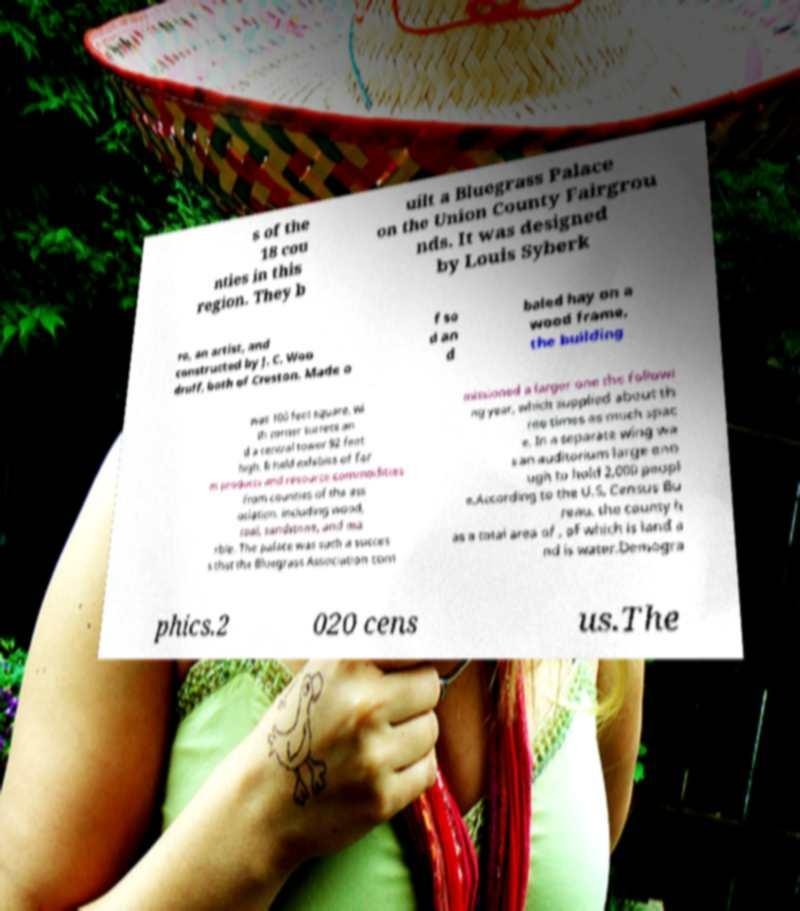Please read and relay the text visible in this image. What does it say? s of the 18 cou nties in this region. They b uilt a Bluegrass Palace on the Union County Fairgrou nds. It was designed by Louis Syberk ro, an artist, and constructed by J. C. Woo druff, both of Creston. Made o f so d an d baled hay on a wood frame, the building was 100 feet square, wi th corner turrets an d a central tower 92 feet high. It held exhibits of far m products and resource commodities from counties of the ass ociation, including wood, coal, sandstone, and ma rble. The palace was such a succes s that the Bluegrass Association com missioned a larger one the followi ng year, which supplied about th ree times as much spac e. In a separate wing wa s an auditorium large eno ugh to hold 2,000 peopl e.According to the U.S. Census Bu reau, the county h as a total area of , of which is land a nd is water.Demogra phics.2 020 cens us.The 